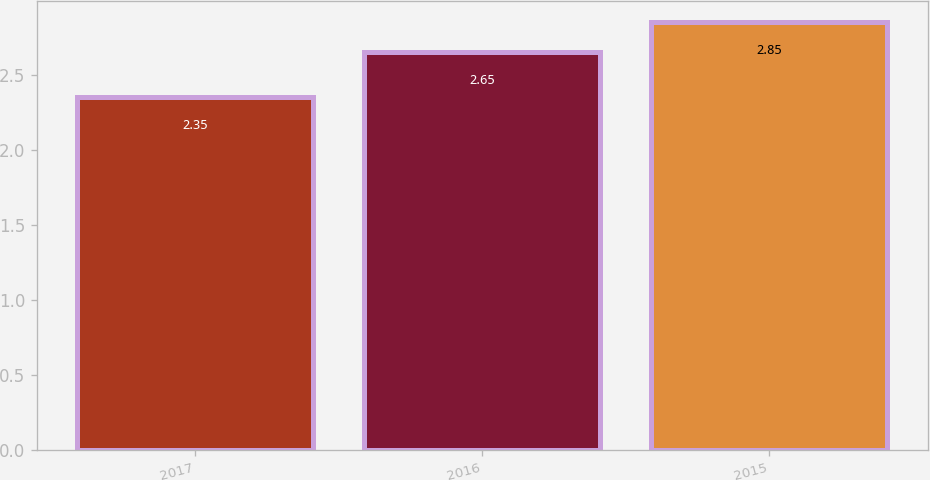Convert chart to OTSL. <chart><loc_0><loc_0><loc_500><loc_500><bar_chart><fcel>2017<fcel>2016<fcel>2015<nl><fcel>2.35<fcel>2.65<fcel>2.85<nl></chart> 